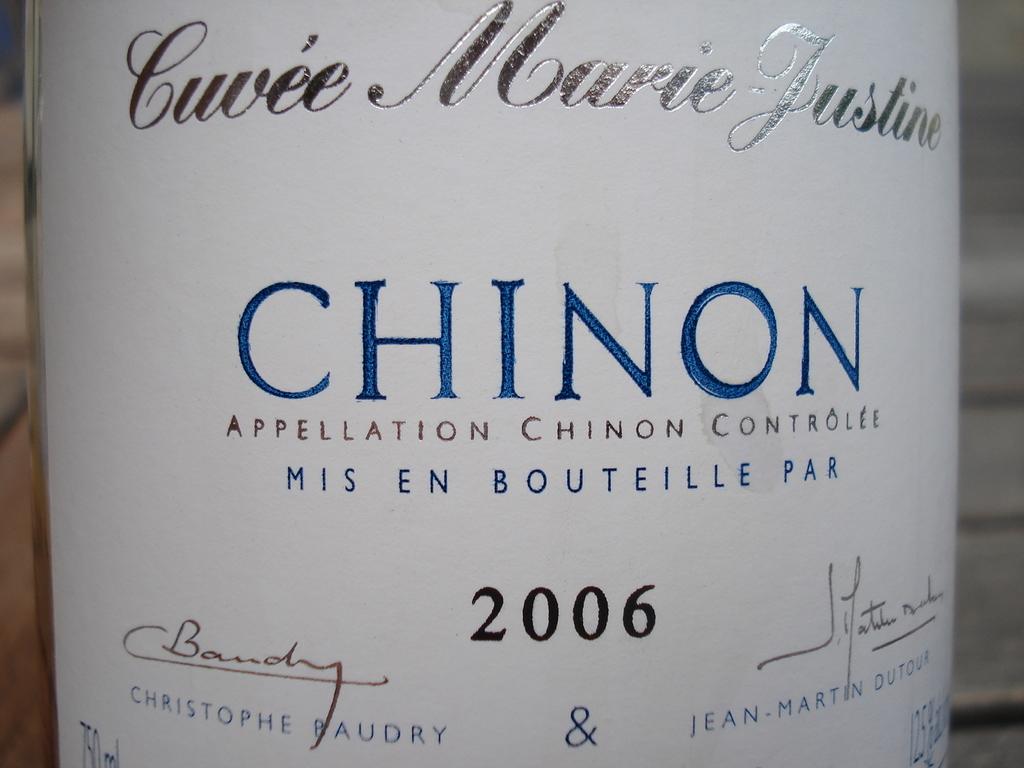What year was this made?
Offer a terse response. 2006. What word is in large blue letters?
Ensure brevity in your answer.  Chinon. 